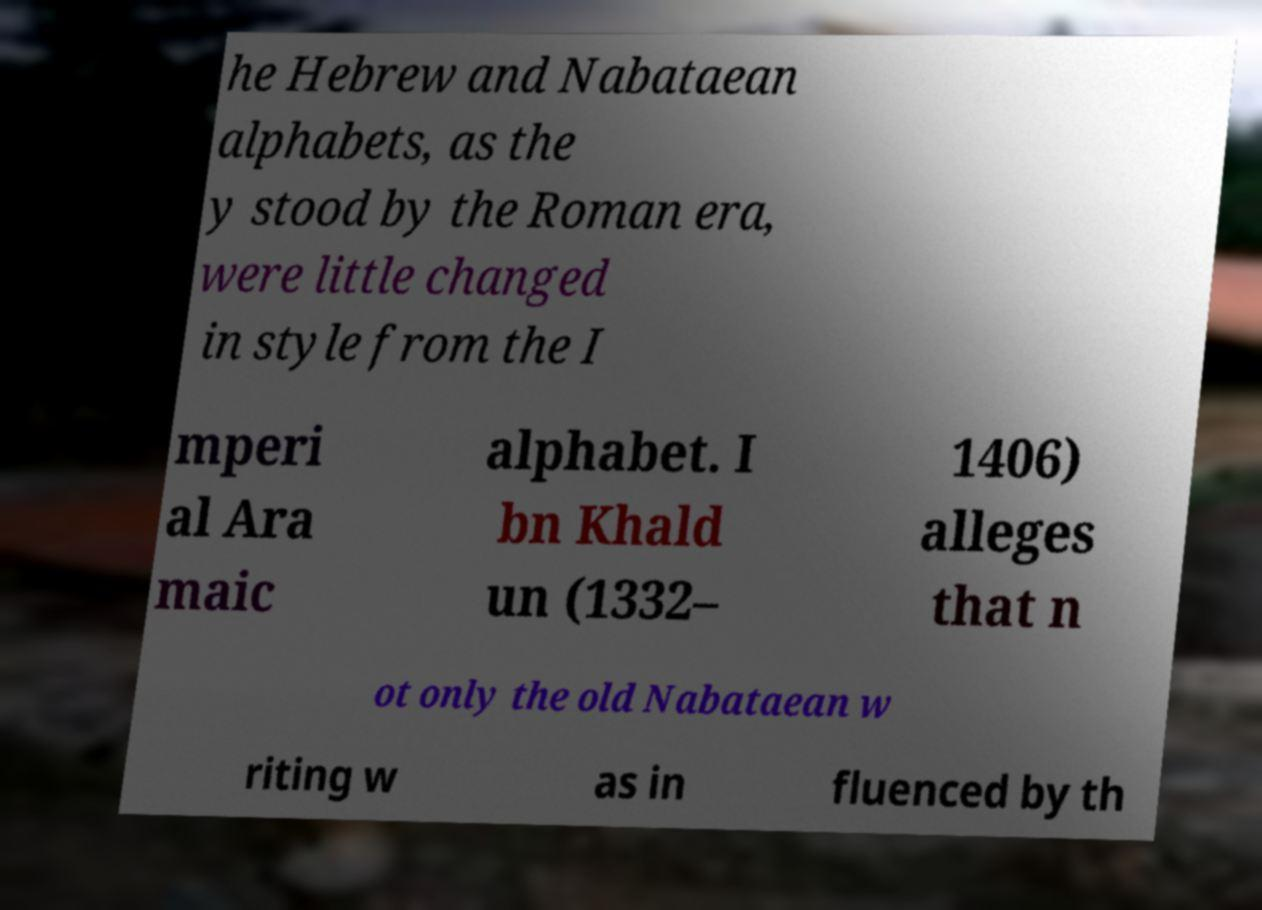What messages or text are displayed in this image? I need them in a readable, typed format. he Hebrew and Nabataean alphabets, as the y stood by the Roman era, were little changed in style from the I mperi al Ara maic alphabet. I bn Khald un (1332– 1406) alleges that n ot only the old Nabataean w riting w as in fluenced by th 